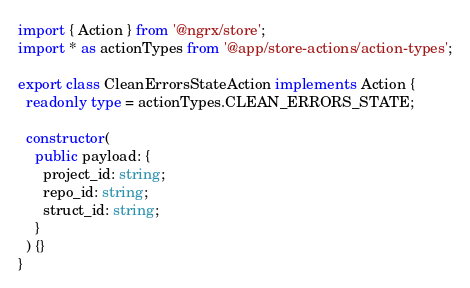<code> <loc_0><loc_0><loc_500><loc_500><_TypeScript_>import { Action } from '@ngrx/store';
import * as actionTypes from '@app/store-actions/action-types';

export class CleanErrorsStateAction implements Action {
  readonly type = actionTypes.CLEAN_ERRORS_STATE;

  constructor(
    public payload: {
      project_id: string;
      repo_id: string;
      struct_id: string;
    }
  ) {}
}
</code> 